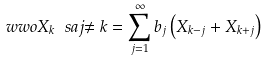Convert formula to latex. <formula><loc_0><loc_0><loc_500><loc_500>\ w w o { X _ { k } } { \ s a j { \ne k } } = \sum _ { j = 1 } ^ { \infty } b _ { j } \left ( X _ { k - j } + X _ { k + j } \right )</formula> 